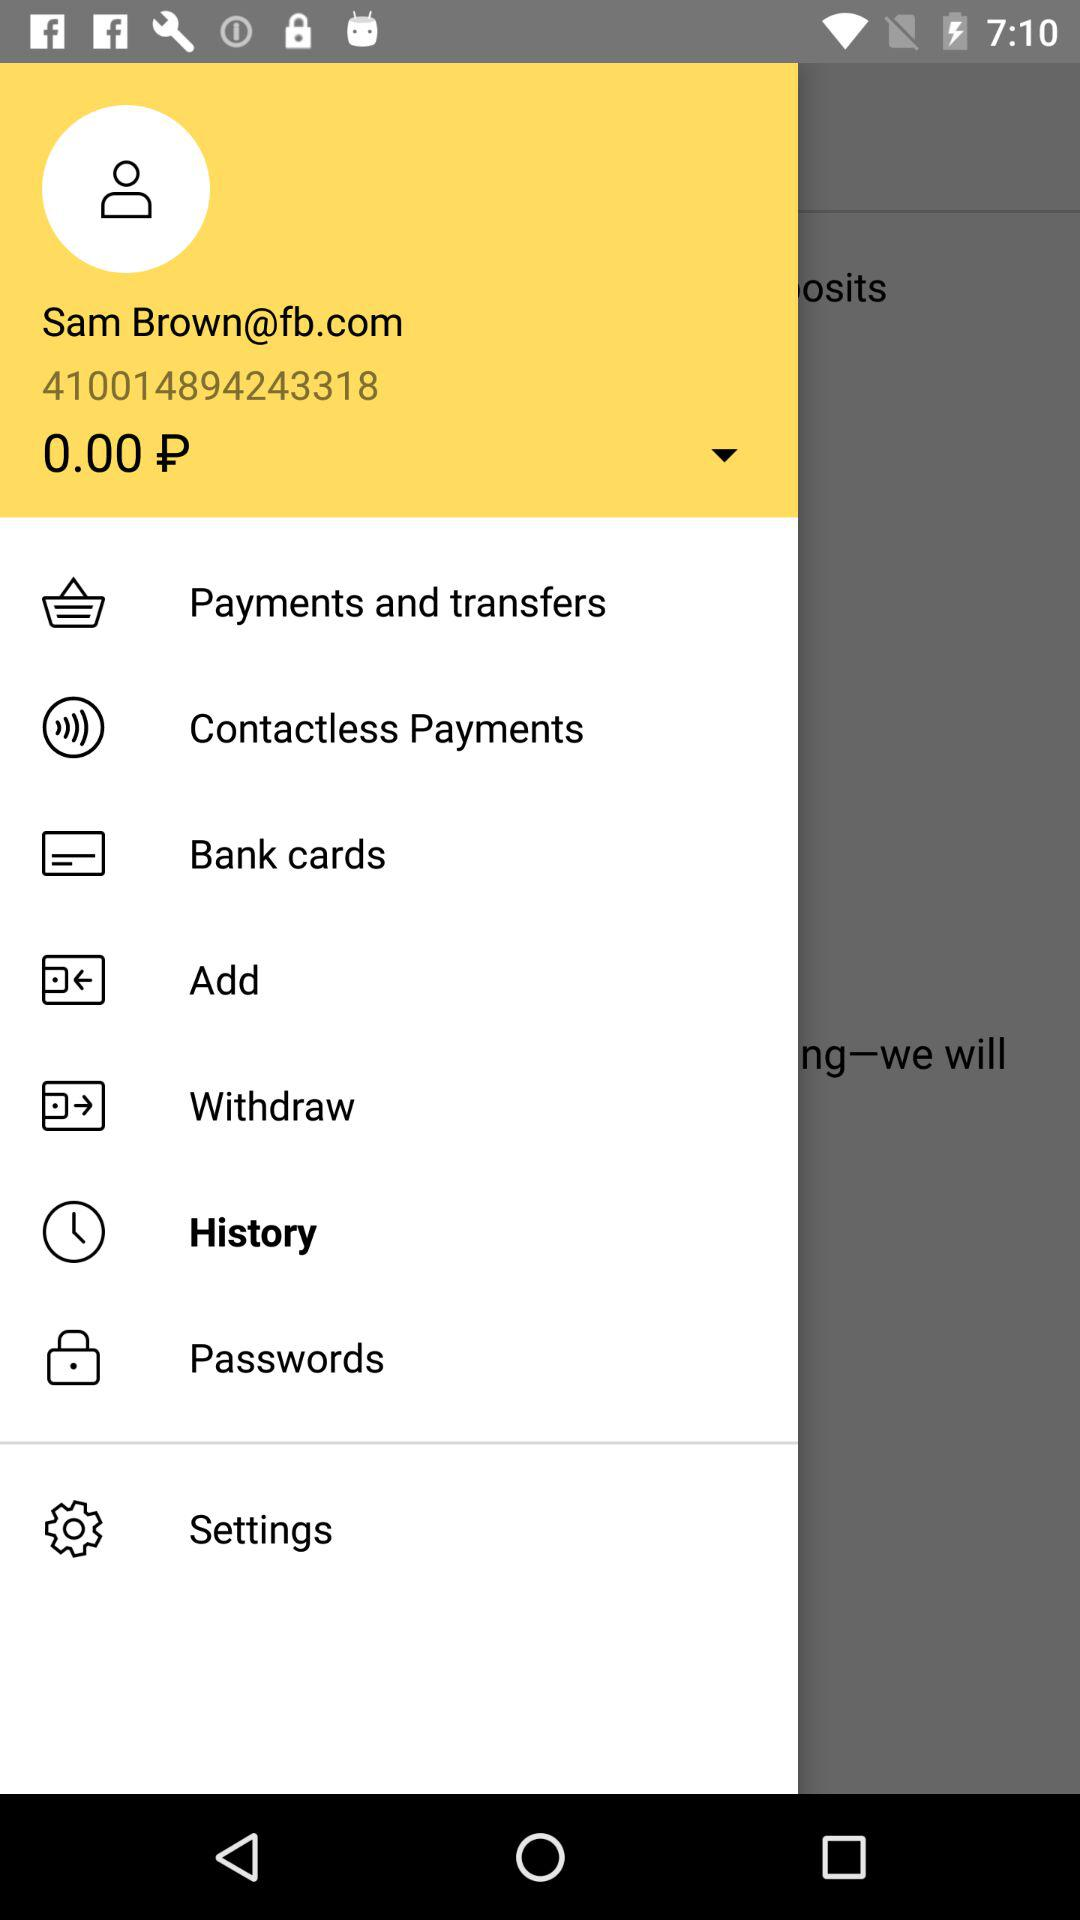Which item is selected? The selected item is "History". 